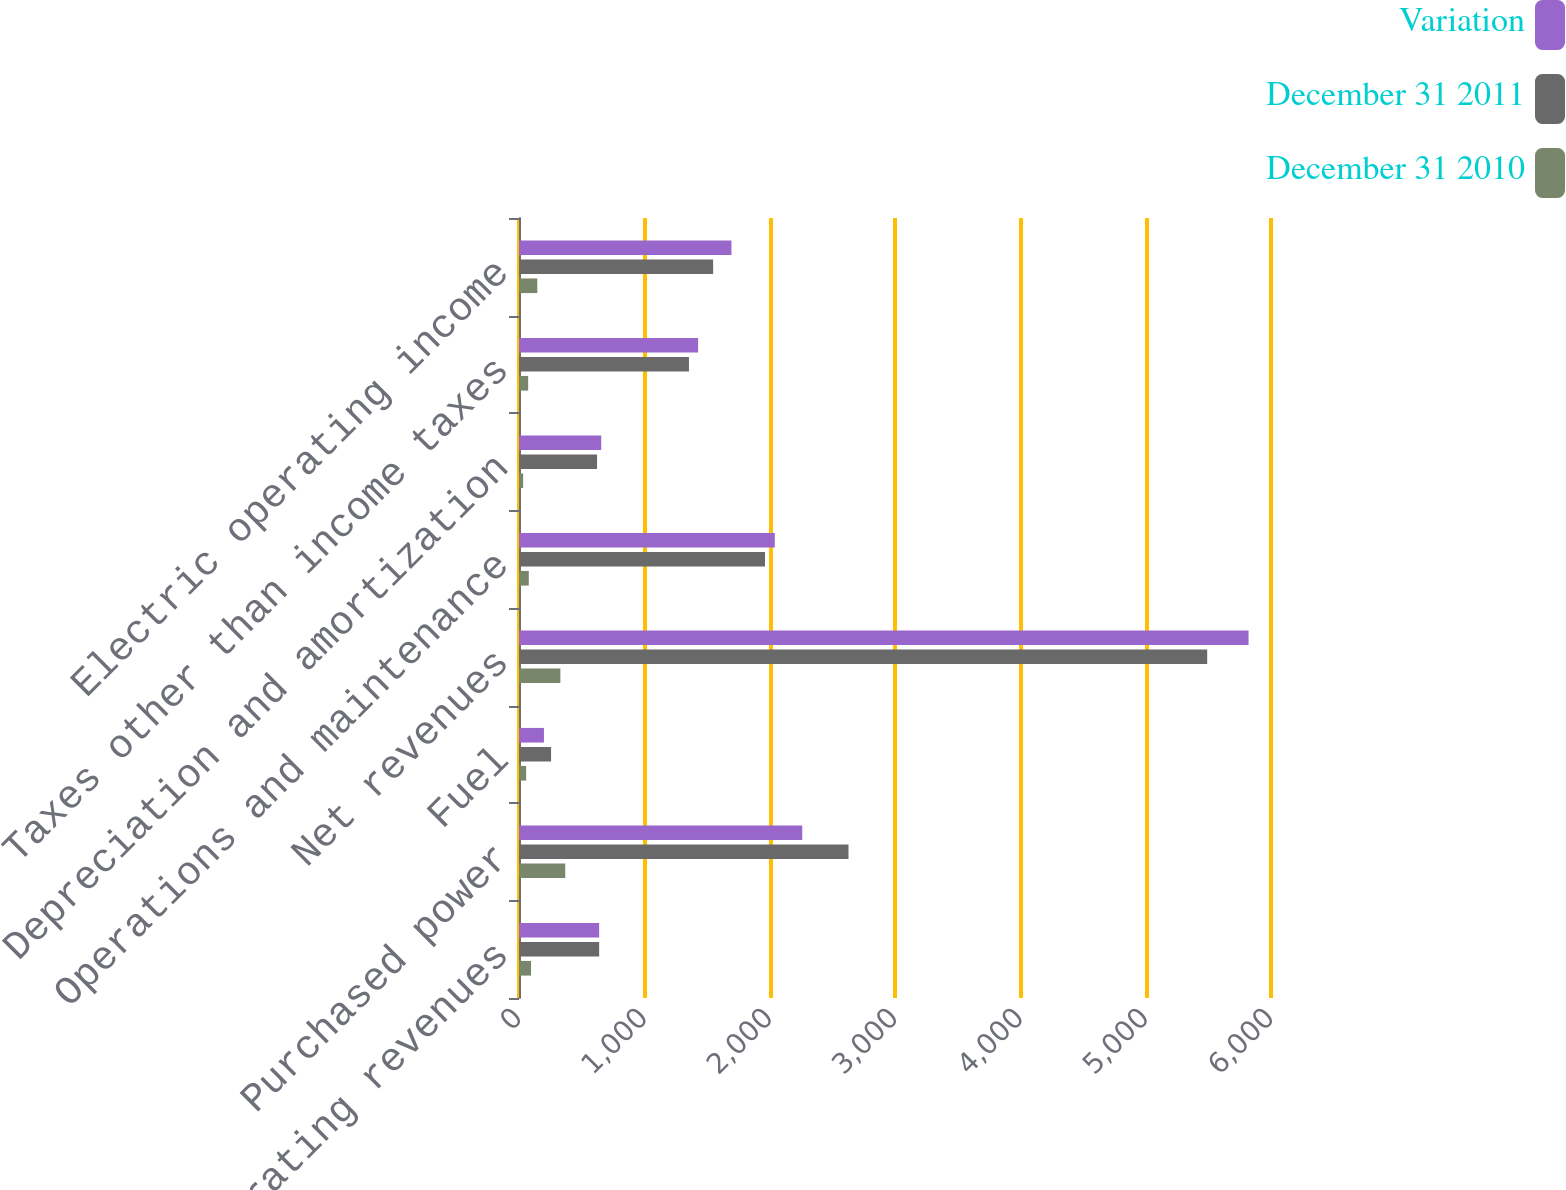<chart> <loc_0><loc_0><loc_500><loc_500><stacked_bar_chart><ecel><fcel>Operating revenues<fcel>Purchased power<fcel>Fuel<fcel>Net revenues<fcel>Operations and maintenance<fcel>Depreciation and amortization<fcel>Taxes other than income taxes<fcel>Electric operating income<nl><fcel>Variation<fcel>639.5<fcel>2260<fcel>199<fcel>5821<fcel>2041<fcel>656<fcel>1429<fcel>1695<nl><fcel>December 31 2011<fcel>639.5<fcel>2629<fcel>256<fcel>5491<fcel>1963<fcel>623<fcel>1356<fcel>1549<nl><fcel>December 31 2010<fcel>96<fcel>369<fcel>57<fcel>330<fcel>78<fcel>33<fcel>73<fcel>146<nl></chart> 